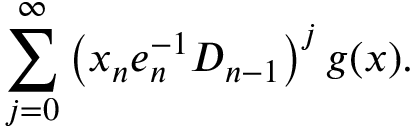<formula> <loc_0><loc_0><loc_500><loc_500>\sum _ { j = 0 } ^ { \infty } \left ( x _ { n } e _ { n } ^ { - 1 } D _ { n - 1 } \right ) ^ { j } g ( x ) .</formula> 